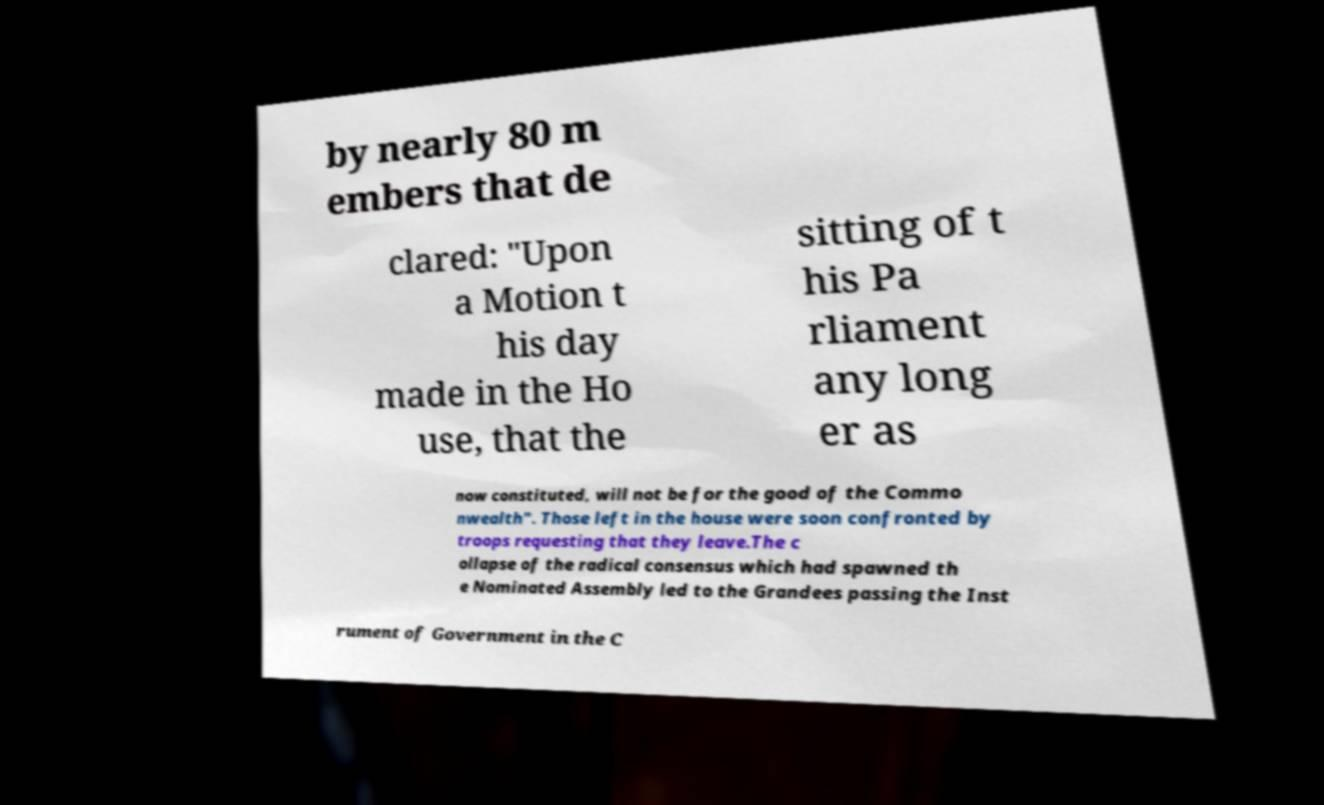Can you accurately transcribe the text from the provided image for me? by nearly 80 m embers that de clared: "Upon a Motion t his day made in the Ho use, that the sitting of t his Pa rliament any long er as now constituted, will not be for the good of the Commo nwealth". Those left in the house were soon confronted by troops requesting that they leave.The c ollapse of the radical consensus which had spawned th e Nominated Assembly led to the Grandees passing the Inst rument of Government in the C 